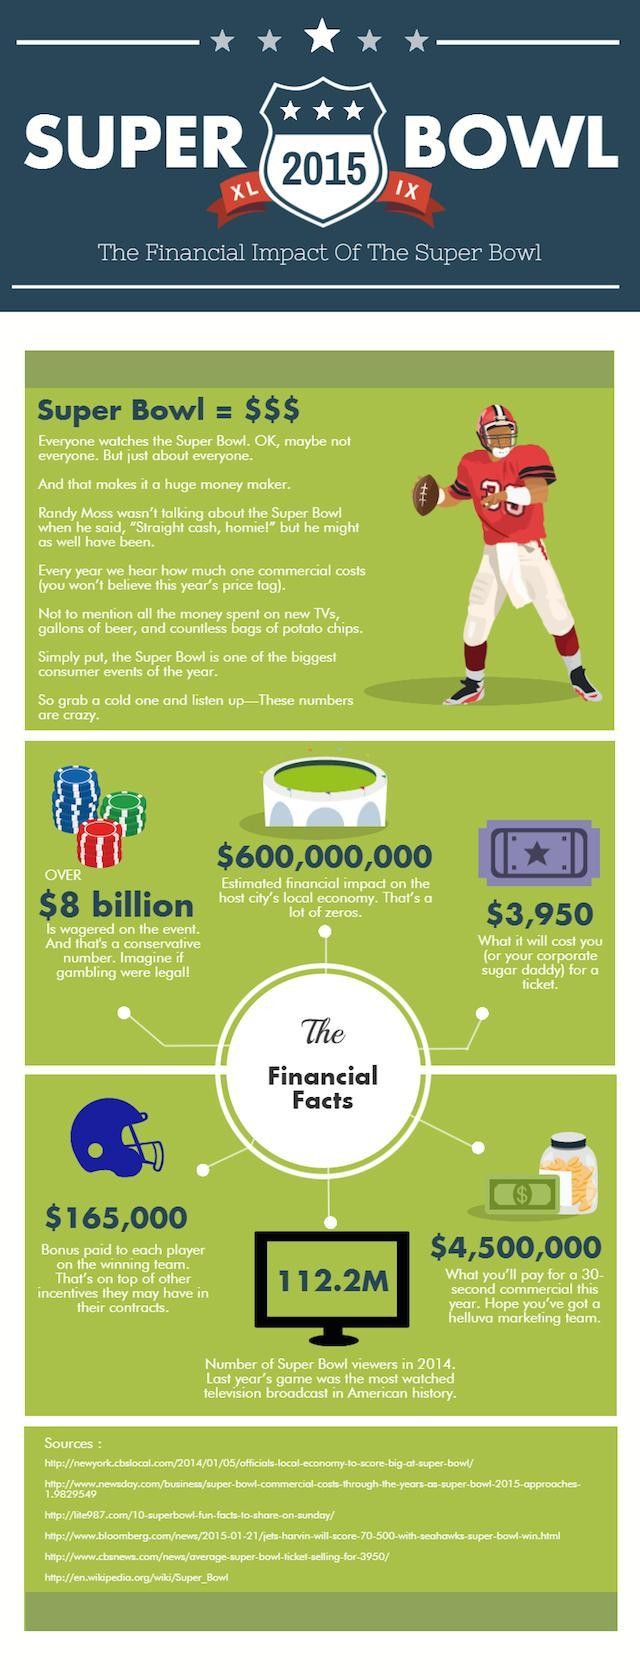How much does Super Bowl events contribute to the economy, $8 Billion, $600 Million, or $112.2 Million?
Answer the question with a short phrase. $600 Million 